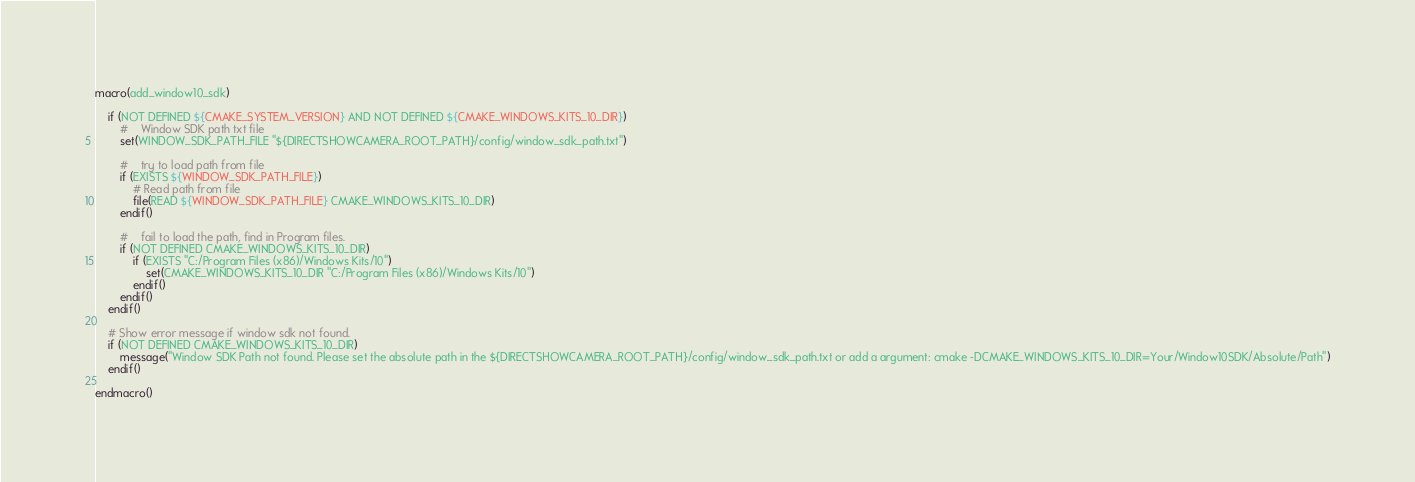<code> <loc_0><loc_0><loc_500><loc_500><_CMake_>macro(add_window10_sdk)

    if (NOT DEFINED ${CMAKE_SYSTEM_VERSION} AND NOT DEFINED ${CMAKE_WINDOWS_KITS_10_DIR})
        #    Window SDK path txt file
        set(WINDOW_SDK_PATH_FILE "${DIRECTSHOWCAMERA_ROOT_PATH}/config/window_sdk_path.txt")

        #    try to load path from file
        if (EXISTS ${WINDOW_SDK_PATH_FILE})
            # Read path from file
            file(READ ${WINDOW_SDK_PATH_FILE} CMAKE_WINDOWS_KITS_10_DIR)
        endif()

        #    fail to load the path, find in Program files.
        if (NOT DEFINED CMAKE_WINDOWS_KITS_10_DIR)
            if (EXISTS "C:/Program Files (x86)/Windows Kits/10")
                set(CMAKE_WINDOWS_KITS_10_DIR "C:/Program Files (x86)/Windows Kits/10")
            endif()
        endif()
    endif()

    # Show error message if window sdk not found.
    if (NOT DEFINED CMAKE_WINDOWS_KITS_10_DIR)
        message("Window SDK Path not found. Please set the absolute path in the ${DIRECTSHOWCAMERA_ROOT_PATH}/config/window_sdk_path.txt or add a argument: cmake -DCMAKE_WINDOWS_KITS_10_DIR=Your/Window10SDK/Absolute/Path")
    endif()

endmacro()</code> 